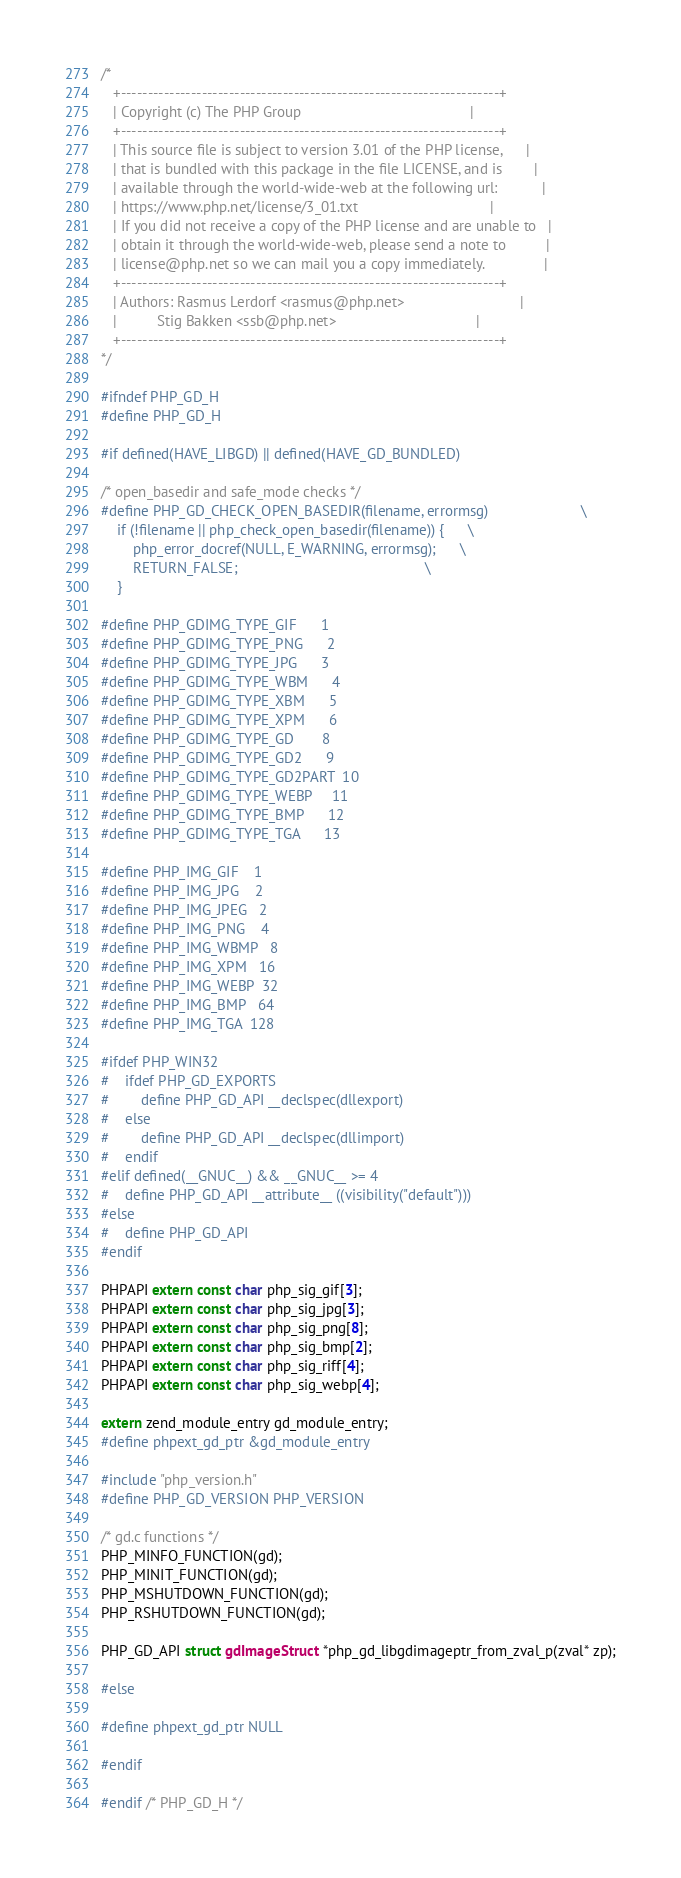Convert code to text. <code><loc_0><loc_0><loc_500><loc_500><_C_>/*
   +----------------------------------------------------------------------+
   | Copyright (c) The PHP Group                                          |
   +----------------------------------------------------------------------+
   | This source file is subject to version 3.01 of the PHP license,      |
   | that is bundled with this package in the file LICENSE, and is        |
   | available through the world-wide-web at the following url:           |
   | https://www.php.net/license/3_01.txt                                 |
   | If you did not receive a copy of the PHP license and are unable to   |
   | obtain it through the world-wide-web, please send a note to          |
   | license@php.net so we can mail you a copy immediately.               |
   +----------------------------------------------------------------------+
   | Authors: Rasmus Lerdorf <rasmus@php.net>                             |
   |          Stig Bakken <ssb@php.net>                                   |
   +----------------------------------------------------------------------+
*/

#ifndef PHP_GD_H
#define PHP_GD_H

#if defined(HAVE_LIBGD) || defined(HAVE_GD_BUNDLED)

/* open_basedir and safe_mode checks */
#define PHP_GD_CHECK_OPEN_BASEDIR(filename, errormsg)                       \
	if (!filename || php_check_open_basedir(filename)) {      \
		php_error_docref(NULL, E_WARNING, errormsg);      \
		RETURN_FALSE;                                               \
	}

#define PHP_GDIMG_TYPE_GIF      1
#define PHP_GDIMG_TYPE_PNG      2
#define PHP_GDIMG_TYPE_JPG      3
#define PHP_GDIMG_TYPE_WBM      4
#define PHP_GDIMG_TYPE_XBM      5
#define PHP_GDIMG_TYPE_XPM      6
#define PHP_GDIMG_TYPE_GD       8
#define PHP_GDIMG_TYPE_GD2      9
#define PHP_GDIMG_TYPE_GD2PART  10
#define PHP_GDIMG_TYPE_WEBP     11
#define PHP_GDIMG_TYPE_BMP      12
#define PHP_GDIMG_TYPE_TGA      13

#define PHP_IMG_GIF    1
#define PHP_IMG_JPG    2
#define PHP_IMG_JPEG   2
#define PHP_IMG_PNG    4
#define PHP_IMG_WBMP   8
#define PHP_IMG_XPM   16
#define PHP_IMG_WEBP  32
#define PHP_IMG_BMP   64
#define PHP_IMG_TGA  128

#ifdef PHP_WIN32
#	ifdef PHP_GD_EXPORTS
#		define PHP_GD_API __declspec(dllexport)
#	else
#		define PHP_GD_API __declspec(dllimport)
#	endif
#elif defined(__GNUC__) && __GNUC__ >= 4
#	define PHP_GD_API __attribute__ ((visibility("default")))
#else
#	define PHP_GD_API
#endif

PHPAPI extern const char php_sig_gif[3];
PHPAPI extern const char php_sig_jpg[3];
PHPAPI extern const char php_sig_png[8];
PHPAPI extern const char php_sig_bmp[2];
PHPAPI extern const char php_sig_riff[4];
PHPAPI extern const char php_sig_webp[4];

extern zend_module_entry gd_module_entry;
#define phpext_gd_ptr &gd_module_entry

#include "php_version.h"
#define PHP_GD_VERSION PHP_VERSION

/* gd.c functions */
PHP_MINFO_FUNCTION(gd);
PHP_MINIT_FUNCTION(gd);
PHP_MSHUTDOWN_FUNCTION(gd);
PHP_RSHUTDOWN_FUNCTION(gd);

PHP_GD_API struct gdImageStruct *php_gd_libgdimageptr_from_zval_p(zval* zp);

#else

#define phpext_gd_ptr NULL

#endif

#endif /* PHP_GD_H */
</code> 